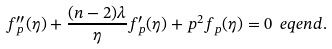Convert formula to latex. <formula><loc_0><loc_0><loc_500><loc_500>f _ { p } ^ { \prime \prime } ( \eta ) + \frac { ( n - 2 ) \lambda } { \eta } f _ { p } ^ { \prime } ( \eta ) + p ^ { 2 } f _ { p } ( \eta ) = 0 \ e q e n d { . }</formula> 